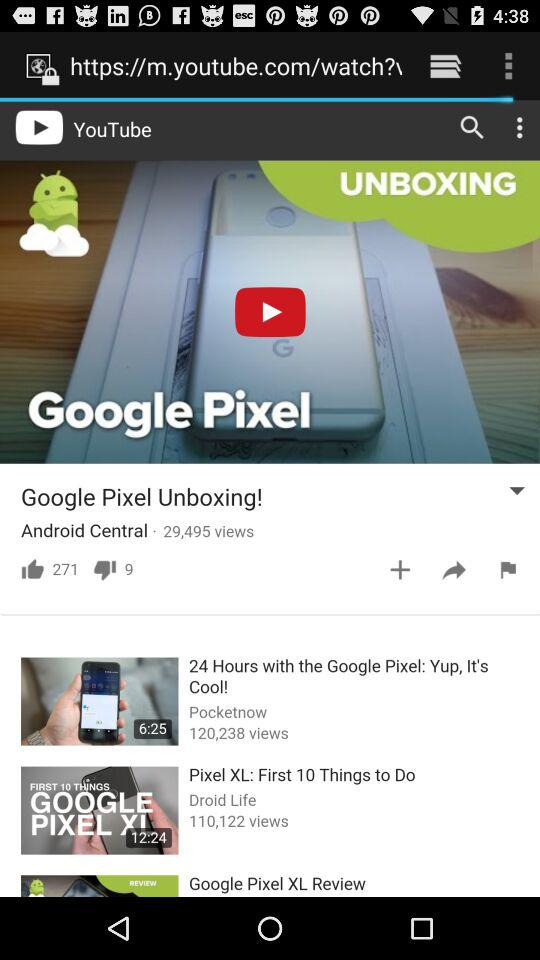How many views does the video with the most views have?
Answer the question using a single word or phrase. 120,238 